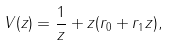Convert formula to latex. <formula><loc_0><loc_0><loc_500><loc_500>V ( z ) = \frac { 1 } { z } + z ( r _ { 0 } + r _ { 1 } z ) ,</formula> 